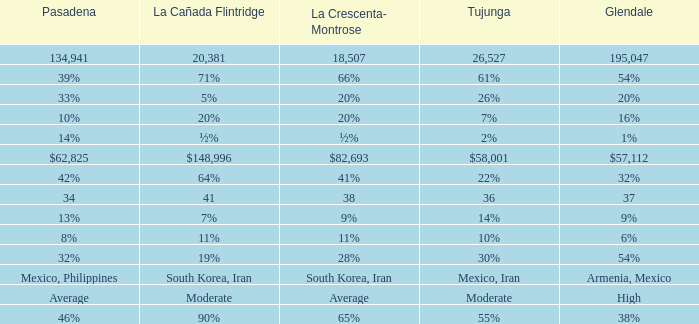When Tujunga is moderate, what is La Crescenta-Montrose? Average. 